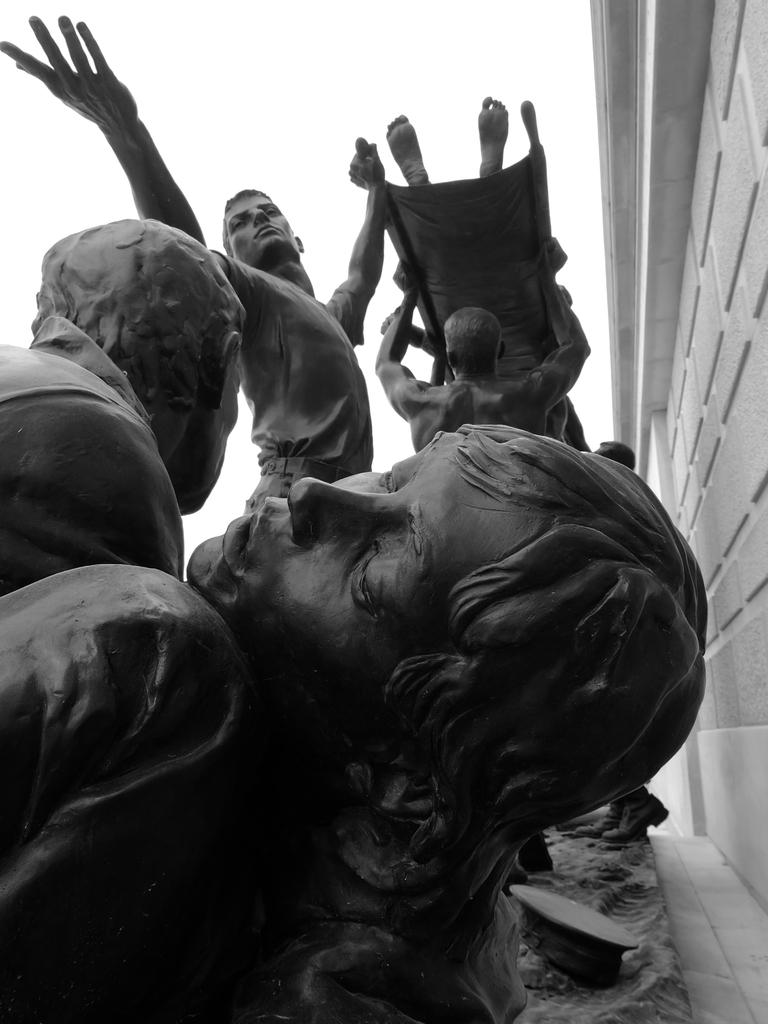What type of art is present in the image? There are sculptures in the image. What is located on the right side of the image? There is a wall on the right side of the image. What is visible at the top of the image? The sky is visible at the top of the image. Can you tell me who won the argument depicted in the sculptures? There is no argument depicted in the sculptures; they are simply art pieces. What phase is the moon in the image? There is no moon present in the image; only sculptures, a wall, and the sky are visible. 